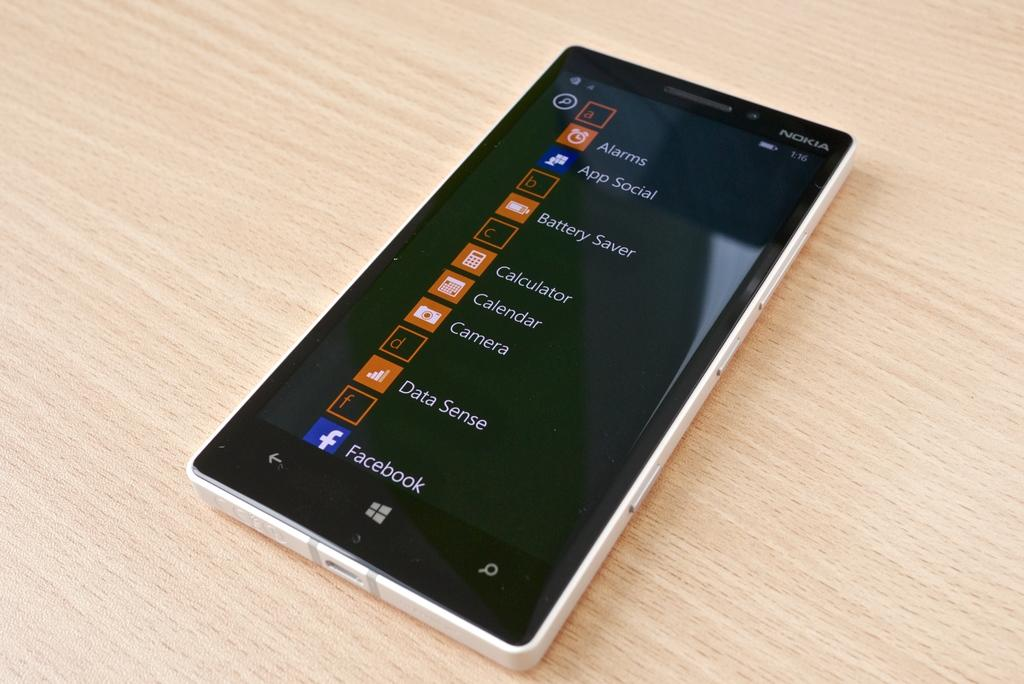<image>
Relay a brief, clear account of the picture shown. A  Nokia phone laying on a wood table with its app screen up. 